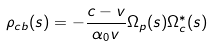<formula> <loc_0><loc_0><loc_500><loc_500>\rho _ { c b } ( s ) = - \frac { c - v } { \alpha _ { 0 } v } \Omega _ { p } ( s ) \Omega _ { c } ^ { \ast } ( s )</formula> 